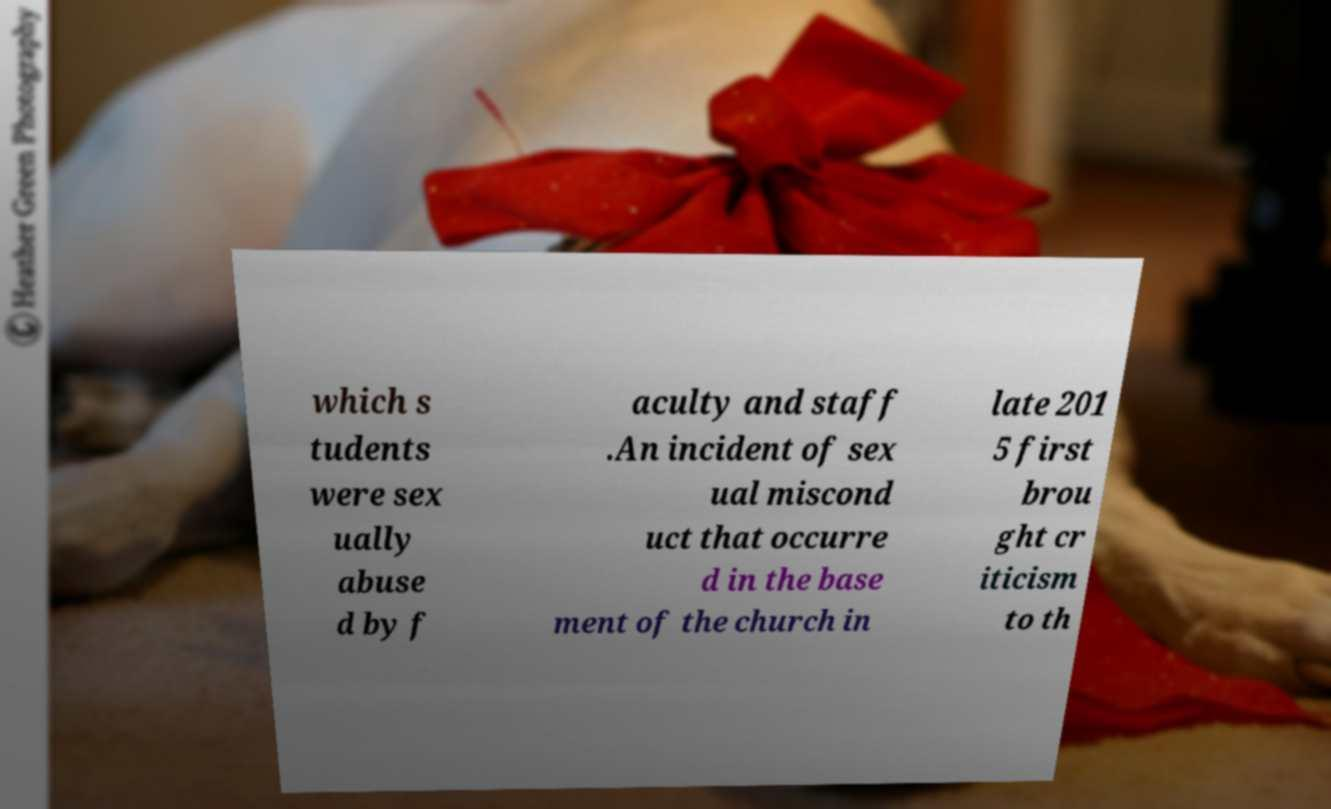There's text embedded in this image that I need extracted. Can you transcribe it verbatim? which s tudents were sex ually abuse d by f aculty and staff .An incident of sex ual miscond uct that occurre d in the base ment of the church in late 201 5 first brou ght cr iticism to th 